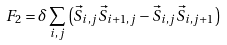<formula> <loc_0><loc_0><loc_500><loc_500>F _ { 2 } = \delta \sum _ { i , j } \left ( \vec { S } _ { i , j } \vec { S } _ { i + 1 , j } - \vec { S } _ { i , j } \vec { S } _ { i , j + 1 } \right )</formula> 